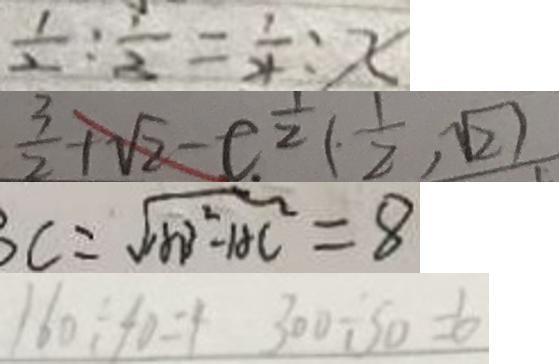Convert formula to latex. <formula><loc_0><loc_0><loc_500><loc_500>\frac { 1 } { 2 } : \frac { 1 } { 3 } = \frac { 1 } { 4 } : x 
 \frac { 3 } { 2 } + \sqrt { 2 } - c ^ { \frac { 1 } { 2 } } ( \frac { 1 } { 2 } , \sqrt { 2 } ) 
 B C = \sqrt { A B ^ { 2 } - A C ^ { 2 } } = 8 
 1 6 0 \div 4 = 4 3 0 0 \div 5 0 = 6</formula> 